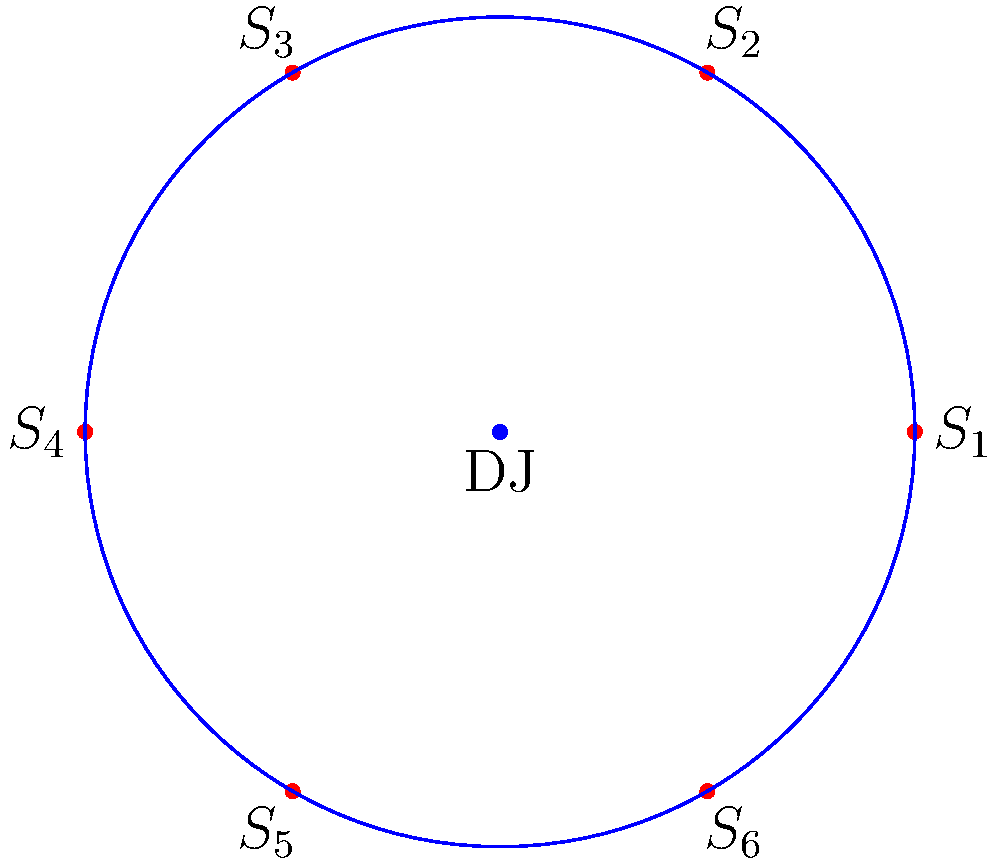In a circular DJ booth setup, 6 speakers are arranged symmetrically as shown in the diagram. The dihedral group $D_6$ describes the symmetries of this arrangement. How many elements are in the subgroup of $D_6$ that fixes the position of speaker $S_1$? Let's approach this step-by-step:

1) First, recall that the dihedral group $D_6$ has $2n = 12$ elements, where $n=6$ is the number of vertices (speakers in this case).

2) The elements of $D_6$ consist of:
   - 6 rotations (including the identity)
   - 6 reflections

3) To fix the position of $S_1$, we can:
   a) Do nothing (identity element)
   b) Reflect across the line that passes through $S_1$ and the center

4) The reflection across the line through $S_1$ and the center will keep $S_1$ in place while swapping the other speakers.

5) Any rotation other than the identity will move $S_1$, so rotations (except identity) are not in our subgroup.

6) Any reflection that doesn't pass through $S_1$ will move $S_1$, so these are not in our subgroup.

7) Therefore, our subgroup consists of only two elements:
   - The identity element
   - The reflection across the line through $S_1$ and the center

8) This subgroup is isomorphic to $C_2$, the cyclic group of order 2.
Answer: 2 